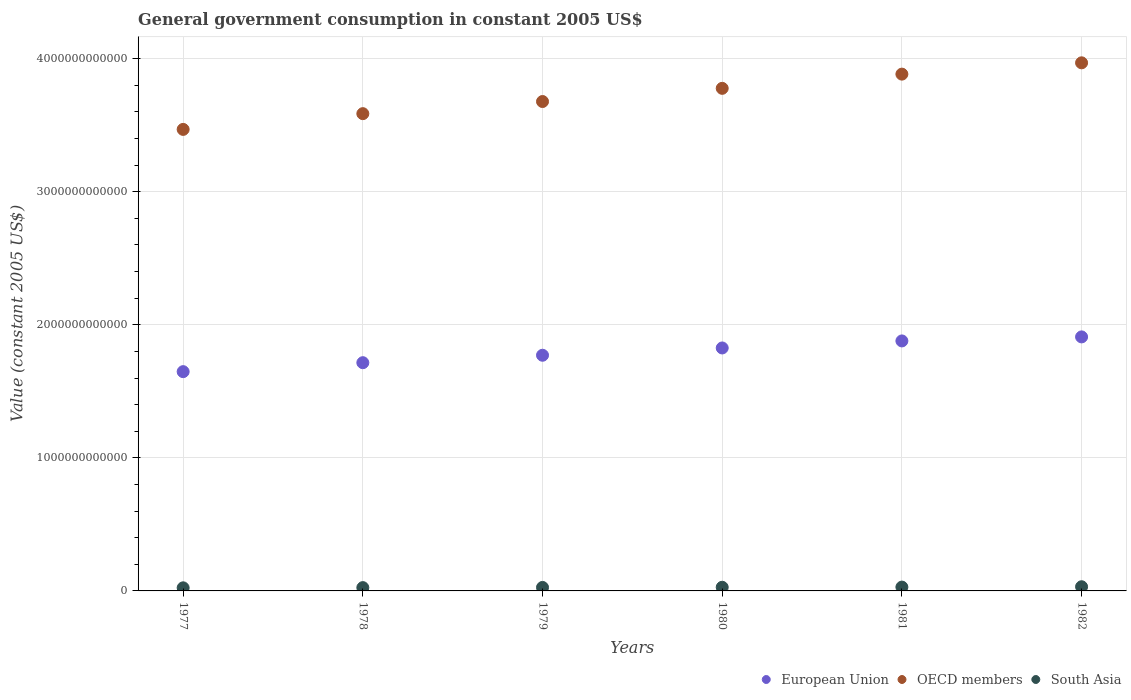What is the government conusmption in OECD members in 1978?
Make the answer very short. 3.59e+12. Across all years, what is the maximum government conusmption in OECD members?
Offer a very short reply. 3.97e+12. Across all years, what is the minimum government conusmption in South Asia?
Provide a short and direct response. 2.33e+1. In which year was the government conusmption in European Union maximum?
Make the answer very short. 1982. In which year was the government conusmption in OECD members minimum?
Provide a short and direct response. 1977. What is the total government conusmption in European Union in the graph?
Provide a succinct answer. 1.07e+13. What is the difference between the government conusmption in European Union in 1977 and that in 1980?
Offer a terse response. -1.78e+11. What is the difference between the government conusmption in South Asia in 1979 and the government conusmption in OECD members in 1981?
Your answer should be compact. -3.86e+12. What is the average government conusmption in European Union per year?
Give a very brief answer. 1.79e+12. In the year 1981, what is the difference between the government conusmption in European Union and government conusmption in OECD members?
Your answer should be compact. -2.01e+12. In how many years, is the government conusmption in OECD members greater than 800000000000 US$?
Provide a short and direct response. 6. What is the ratio of the government conusmption in European Union in 1980 to that in 1982?
Provide a short and direct response. 0.96. Is the government conusmption in European Union in 1979 less than that in 1982?
Ensure brevity in your answer.  Yes. Is the difference between the government conusmption in European Union in 1978 and 1979 greater than the difference between the government conusmption in OECD members in 1978 and 1979?
Make the answer very short. Yes. What is the difference between the highest and the second highest government conusmption in OECD members?
Your answer should be very brief. 8.49e+1. What is the difference between the highest and the lowest government conusmption in South Asia?
Offer a very short reply. 8.10e+09. In how many years, is the government conusmption in European Union greater than the average government conusmption in European Union taken over all years?
Your answer should be very brief. 3. Is it the case that in every year, the sum of the government conusmption in European Union and government conusmption in South Asia  is greater than the government conusmption in OECD members?
Make the answer very short. No. Is the government conusmption in European Union strictly greater than the government conusmption in South Asia over the years?
Your answer should be compact. Yes. Is the government conusmption in European Union strictly less than the government conusmption in South Asia over the years?
Offer a very short reply. No. How many years are there in the graph?
Keep it short and to the point. 6. What is the difference between two consecutive major ticks on the Y-axis?
Your answer should be very brief. 1.00e+12. Does the graph contain grids?
Give a very brief answer. Yes. What is the title of the graph?
Offer a very short reply. General government consumption in constant 2005 US$. What is the label or title of the Y-axis?
Keep it short and to the point. Value (constant 2005 US$). What is the Value (constant 2005 US$) in European Union in 1977?
Your answer should be very brief. 1.65e+12. What is the Value (constant 2005 US$) of OECD members in 1977?
Make the answer very short. 3.47e+12. What is the Value (constant 2005 US$) of South Asia in 1977?
Offer a terse response. 2.33e+1. What is the Value (constant 2005 US$) in European Union in 1978?
Your answer should be compact. 1.72e+12. What is the Value (constant 2005 US$) of OECD members in 1978?
Keep it short and to the point. 3.59e+12. What is the Value (constant 2005 US$) in South Asia in 1978?
Keep it short and to the point. 2.48e+1. What is the Value (constant 2005 US$) of European Union in 1979?
Offer a terse response. 1.77e+12. What is the Value (constant 2005 US$) in OECD members in 1979?
Ensure brevity in your answer.  3.68e+12. What is the Value (constant 2005 US$) of South Asia in 1979?
Give a very brief answer. 2.62e+1. What is the Value (constant 2005 US$) in European Union in 1980?
Make the answer very short. 1.83e+12. What is the Value (constant 2005 US$) in OECD members in 1980?
Keep it short and to the point. 3.78e+12. What is the Value (constant 2005 US$) in South Asia in 1980?
Offer a very short reply. 2.74e+1. What is the Value (constant 2005 US$) of European Union in 1981?
Ensure brevity in your answer.  1.88e+12. What is the Value (constant 2005 US$) of OECD members in 1981?
Give a very brief answer. 3.88e+12. What is the Value (constant 2005 US$) in South Asia in 1981?
Make the answer very short. 2.88e+1. What is the Value (constant 2005 US$) of European Union in 1982?
Offer a terse response. 1.91e+12. What is the Value (constant 2005 US$) in OECD members in 1982?
Your answer should be compact. 3.97e+12. What is the Value (constant 2005 US$) of South Asia in 1982?
Keep it short and to the point. 3.14e+1. Across all years, what is the maximum Value (constant 2005 US$) of European Union?
Provide a succinct answer. 1.91e+12. Across all years, what is the maximum Value (constant 2005 US$) in OECD members?
Your answer should be very brief. 3.97e+12. Across all years, what is the maximum Value (constant 2005 US$) of South Asia?
Give a very brief answer. 3.14e+1. Across all years, what is the minimum Value (constant 2005 US$) of European Union?
Make the answer very short. 1.65e+12. Across all years, what is the minimum Value (constant 2005 US$) of OECD members?
Keep it short and to the point. 3.47e+12. Across all years, what is the minimum Value (constant 2005 US$) of South Asia?
Offer a terse response. 2.33e+1. What is the total Value (constant 2005 US$) of European Union in the graph?
Your answer should be compact. 1.07e+13. What is the total Value (constant 2005 US$) in OECD members in the graph?
Keep it short and to the point. 2.24e+13. What is the total Value (constant 2005 US$) in South Asia in the graph?
Ensure brevity in your answer.  1.62e+11. What is the difference between the Value (constant 2005 US$) in European Union in 1977 and that in 1978?
Provide a succinct answer. -6.73e+1. What is the difference between the Value (constant 2005 US$) in OECD members in 1977 and that in 1978?
Provide a short and direct response. -1.18e+11. What is the difference between the Value (constant 2005 US$) in South Asia in 1977 and that in 1978?
Make the answer very short. -1.54e+09. What is the difference between the Value (constant 2005 US$) of European Union in 1977 and that in 1979?
Provide a succinct answer. -1.23e+11. What is the difference between the Value (constant 2005 US$) of OECD members in 1977 and that in 1979?
Offer a terse response. -2.10e+11. What is the difference between the Value (constant 2005 US$) of South Asia in 1977 and that in 1979?
Offer a terse response. -2.97e+09. What is the difference between the Value (constant 2005 US$) in European Union in 1977 and that in 1980?
Offer a very short reply. -1.78e+11. What is the difference between the Value (constant 2005 US$) of OECD members in 1977 and that in 1980?
Keep it short and to the point. -3.09e+11. What is the difference between the Value (constant 2005 US$) in South Asia in 1977 and that in 1980?
Keep it short and to the point. -4.13e+09. What is the difference between the Value (constant 2005 US$) in European Union in 1977 and that in 1981?
Make the answer very short. -2.31e+11. What is the difference between the Value (constant 2005 US$) in OECD members in 1977 and that in 1981?
Your answer should be very brief. -4.15e+11. What is the difference between the Value (constant 2005 US$) in South Asia in 1977 and that in 1981?
Your answer should be compact. -5.49e+09. What is the difference between the Value (constant 2005 US$) of European Union in 1977 and that in 1982?
Offer a very short reply. -2.61e+11. What is the difference between the Value (constant 2005 US$) in OECD members in 1977 and that in 1982?
Ensure brevity in your answer.  -5.00e+11. What is the difference between the Value (constant 2005 US$) in South Asia in 1977 and that in 1982?
Make the answer very short. -8.10e+09. What is the difference between the Value (constant 2005 US$) in European Union in 1978 and that in 1979?
Ensure brevity in your answer.  -5.59e+1. What is the difference between the Value (constant 2005 US$) in OECD members in 1978 and that in 1979?
Provide a short and direct response. -9.12e+1. What is the difference between the Value (constant 2005 US$) in South Asia in 1978 and that in 1979?
Your response must be concise. -1.43e+09. What is the difference between the Value (constant 2005 US$) of European Union in 1978 and that in 1980?
Ensure brevity in your answer.  -1.11e+11. What is the difference between the Value (constant 2005 US$) in OECD members in 1978 and that in 1980?
Keep it short and to the point. -1.90e+11. What is the difference between the Value (constant 2005 US$) in South Asia in 1978 and that in 1980?
Your response must be concise. -2.59e+09. What is the difference between the Value (constant 2005 US$) of European Union in 1978 and that in 1981?
Offer a very short reply. -1.64e+11. What is the difference between the Value (constant 2005 US$) in OECD members in 1978 and that in 1981?
Offer a terse response. -2.97e+11. What is the difference between the Value (constant 2005 US$) in South Asia in 1978 and that in 1981?
Give a very brief answer. -3.95e+09. What is the difference between the Value (constant 2005 US$) in European Union in 1978 and that in 1982?
Keep it short and to the point. -1.94e+11. What is the difference between the Value (constant 2005 US$) of OECD members in 1978 and that in 1982?
Provide a succinct answer. -3.82e+11. What is the difference between the Value (constant 2005 US$) of South Asia in 1978 and that in 1982?
Keep it short and to the point. -6.56e+09. What is the difference between the Value (constant 2005 US$) of European Union in 1979 and that in 1980?
Your response must be concise. -5.47e+1. What is the difference between the Value (constant 2005 US$) in OECD members in 1979 and that in 1980?
Provide a succinct answer. -9.91e+1. What is the difference between the Value (constant 2005 US$) of South Asia in 1979 and that in 1980?
Give a very brief answer. -1.16e+09. What is the difference between the Value (constant 2005 US$) of European Union in 1979 and that in 1981?
Ensure brevity in your answer.  -1.08e+11. What is the difference between the Value (constant 2005 US$) in OECD members in 1979 and that in 1981?
Provide a succinct answer. -2.06e+11. What is the difference between the Value (constant 2005 US$) of South Asia in 1979 and that in 1981?
Offer a very short reply. -2.52e+09. What is the difference between the Value (constant 2005 US$) of European Union in 1979 and that in 1982?
Make the answer very short. -1.38e+11. What is the difference between the Value (constant 2005 US$) in OECD members in 1979 and that in 1982?
Ensure brevity in your answer.  -2.91e+11. What is the difference between the Value (constant 2005 US$) of South Asia in 1979 and that in 1982?
Provide a short and direct response. -5.13e+09. What is the difference between the Value (constant 2005 US$) of European Union in 1980 and that in 1981?
Provide a succinct answer. -5.29e+1. What is the difference between the Value (constant 2005 US$) of OECD members in 1980 and that in 1981?
Offer a terse response. -1.07e+11. What is the difference between the Value (constant 2005 US$) in South Asia in 1980 and that in 1981?
Keep it short and to the point. -1.36e+09. What is the difference between the Value (constant 2005 US$) of European Union in 1980 and that in 1982?
Provide a succinct answer. -8.31e+1. What is the difference between the Value (constant 2005 US$) in OECD members in 1980 and that in 1982?
Keep it short and to the point. -1.92e+11. What is the difference between the Value (constant 2005 US$) in South Asia in 1980 and that in 1982?
Keep it short and to the point. -3.97e+09. What is the difference between the Value (constant 2005 US$) in European Union in 1981 and that in 1982?
Give a very brief answer. -3.03e+1. What is the difference between the Value (constant 2005 US$) of OECD members in 1981 and that in 1982?
Your answer should be very brief. -8.49e+1. What is the difference between the Value (constant 2005 US$) of South Asia in 1981 and that in 1982?
Your response must be concise. -2.61e+09. What is the difference between the Value (constant 2005 US$) in European Union in 1977 and the Value (constant 2005 US$) in OECD members in 1978?
Your answer should be compact. -1.94e+12. What is the difference between the Value (constant 2005 US$) in European Union in 1977 and the Value (constant 2005 US$) in South Asia in 1978?
Make the answer very short. 1.62e+12. What is the difference between the Value (constant 2005 US$) of OECD members in 1977 and the Value (constant 2005 US$) of South Asia in 1978?
Give a very brief answer. 3.44e+12. What is the difference between the Value (constant 2005 US$) of European Union in 1977 and the Value (constant 2005 US$) of OECD members in 1979?
Offer a very short reply. -2.03e+12. What is the difference between the Value (constant 2005 US$) of European Union in 1977 and the Value (constant 2005 US$) of South Asia in 1979?
Your response must be concise. 1.62e+12. What is the difference between the Value (constant 2005 US$) in OECD members in 1977 and the Value (constant 2005 US$) in South Asia in 1979?
Provide a succinct answer. 3.44e+12. What is the difference between the Value (constant 2005 US$) of European Union in 1977 and the Value (constant 2005 US$) of OECD members in 1980?
Ensure brevity in your answer.  -2.13e+12. What is the difference between the Value (constant 2005 US$) in European Union in 1977 and the Value (constant 2005 US$) in South Asia in 1980?
Your answer should be very brief. 1.62e+12. What is the difference between the Value (constant 2005 US$) of OECD members in 1977 and the Value (constant 2005 US$) of South Asia in 1980?
Keep it short and to the point. 3.44e+12. What is the difference between the Value (constant 2005 US$) of European Union in 1977 and the Value (constant 2005 US$) of OECD members in 1981?
Ensure brevity in your answer.  -2.24e+12. What is the difference between the Value (constant 2005 US$) in European Union in 1977 and the Value (constant 2005 US$) in South Asia in 1981?
Your response must be concise. 1.62e+12. What is the difference between the Value (constant 2005 US$) of OECD members in 1977 and the Value (constant 2005 US$) of South Asia in 1981?
Ensure brevity in your answer.  3.44e+12. What is the difference between the Value (constant 2005 US$) of European Union in 1977 and the Value (constant 2005 US$) of OECD members in 1982?
Give a very brief answer. -2.32e+12. What is the difference between the Value (constant 2005 US$) of European Union in 1977 and the Value (constant 2005 US$) of South Asia in 1982?
Your response must be concise. 1.62e+12. What is the difference between the Value (constant 2005 US$) in OECD members in 1977 and the Value (constant 2005 US$) in South Asia in 1982?
Keep it short and to the point. 3.44e+12. What is the difference between the Value (constant 2005 US$) in European Union in 1978 and the Value (constant 2005 US$) in OECD members in 1979?
Provide a short and direct response. -1.96e+12. What is the difference between the Value (constant 2005 US$) in European Union in 1978 and the Value (constant 2005 US$) in South Asia in 1979?
Give a very brief answer. 1.69e+12. What is the difference between the Value (constant 2005 US$) in OECD members in 1978 and the Value (constant 2005 US$) in South Asia in 1979?
Make the answer very short. 3.56e+12. What is the difference between the Value (constant 2005 US$) in European Union in 1978 and the Value (constant 2005 US$) in OECD members in 1980?
Provide a short and direct response. -2.06e+12. What is the difference between the Value (constant 2005 US$) in European Union in 1978 and the Value (constant 2005 US$) in South Asia in 1980?
Offer a very short reply. 1.69e+12. What is the difference between the Value (constant 2005 US$) in OECD members in 1978 and the Value (constant 2005 US$) in South Asia in 1980?
Keep it short and to the point. 3.56e+12. What is the difference between the Value (constant 2005 US$) of European Union in 1978 and the Value (constant 2005 US$) of OECD members in 1981?
Ensure brevity in your answer.  -2.17e+12. What is the difference between the Value (constant 2005 US$) in European Union in 1978 and the Value (constant 2005 US$) in South Asia in 1981?
Offer a terse response. 1.69e+12. What is the difference between the Value (constant 2005 US$) in OECD members in 1978 and the Value (constant 2005 US$) in South Asia in 1981?
Keep it short and to the point. 3.56e+12. What is the difference between the Value (constant 2005 US$) in European Union in 1978 and the Value (constant 2005 US$) in OECD members in 1982?
Your answer should be very brief. -2.25e+12. What is the difference between the Value (constant 2005 US$) of European Union in 1978 and the Value (constant 2005 US$) of South Asia in 1982?
Your response must be concise. 1.68e+12. What is the difference between the Value (constant 2005 US$) in OECD members in 1978 and the Value (constant 2005 US$) in South Asia in 1982?
Make the answer very short. 3.56e+12. What is the difference between the Value (constant 2005 US$) in European Union in 1979 and the Value (constant 2005 US$) in OECD members in 1980?
Provide a short and direct response. -2.01e+12. What is the difference between the Value (constant 2005 US$) of European Union in 1979 and the Value (constant 2005 US$) of South Asia in 1980?
Keep it short and to the point. 1.74e+12. What is the difference between the Value (constant 2005 US$) of OECD members in 1979 and the Value (constant 2005 US$) of South Asia in 1980?
Ensure brevity in your answer.  3.65e+12. What is the difference between the Value (constant 2005 US$) of European Union in 1979 and the Value (constant 2005 US$) of OECD members in 1981?
Make the answer very short. -2.11e+12. What is the difference between the Value (constant 2005 US$) of European Union in 1979 and the Value (constant 2005 US$) of South Asia in 1981?
Keep it short and to the point. 1.74e+12. What is the difference between the Value (constant 2005 US$) of OECD members in 1979 and the Value (constant 2005 US$) of South Asia in 1981?
Ensure brevity in your answer.  3.65e+12. What is the difference between the Value (constant 2005 US$) of European Union in 1979 and the Value (constant 2005 US$) of OECD members in 1982?
Make the answer very short. -2.20e+12. What is the difference between the Value (constant 2005 US$) of European Union in 1979 and the Value (constant 2005 US$) of South Asia in 1982?
Keep it short and to the point. 1.74e+12. What is the difference between the Value (constant 2005 US$) of OECD members in 1979 and the Value (constant 2005 US$) of South Asia in 1982?
Your answer should be very brief. 3.65e+12. What is the difference between the Value (constant 2005 US$) of European Union in 1980 and the Value (constant 2005 US$) of OECD members in 1981?
Offer a terse response. -2.06e+12. What is the difference between the Value (constant 2005 US$) in European Union in 1980 and the Value (constant 2005 US$) in South Asia in 1981?
Your answer should be very brief. 1.80e+12. What is the difference between the Value (constant 2005 US$) of OECD members in 1980 and the Value (constant 2005 US$) of South Asia in 1981?
Keep it short and to the point. 3.75e+12. What is the difference between the Value (constant 2005 US$) in European Union in 1980 and the Value (constant 2005 US$) in OECD members in 1982?
Offer a very short reply. -2.14e+12. What is the difference between the Value (constant 2005 US$) of European Union in 1980 and the Value (constant 2005 US$) of South Asia in 1982?
Your answer should be compact. 1.79e+12. What is the difference between the Value (constant 2005 US$) in OECD members in 1980 and the Value (constant 2005 US$) in South Asia in 1982?
Provide a short and direct response. 3.75e+12. What is the difference between the Value (constant 2005 US$) in European Union in 1981 and the Value (constant 2005 US$) in OECD members in 1982?
Ensure brevity in your answer.  -2.09e+12. What is the difference between the Value (constant 2005 US$) of European Union in 1981 and the Value (constant 2005 US$) of South Asia in 1982?
Your answer should be compact. 1.85e+12. What is the difference between the Value (constant 2005 US$) in OECD members in 1981 and the Value (constant 2005 US$) in South Asia in 1982?
Give a very brief answer. 3.85e+12. What is the average Value (constant 2005 US$) in European Union per year?
Offer a terse response. 1.79e+12. What is the average Value (constant 2005 US$) in OECD members per year?
Give a very brief answer. 3.73e+12. What is the average Value (constant 2005 US$) of South Asia per year?
Provide a short and direct response. 2.70e+1. In the year 1977, what is the difference between the Value (constant 2005 US$) in European Union and Value (constant 2005 US$) in OECD members?
Give a very brief answer. -1.82e+12. In the year 1977, what is the difference between the Value (constant 2005 US$) in European Union and Value (constant 2005 US$) in South Asia?
Offer a terse response. 1.62e+12. In the year 1977, what is the difference between the Value (constant 2005 US$) in OECD members and Value (constant 2005 US$) in South Asia?
Provide a short and direct response. 3.45e+12. In the year 1978, what is the difference between the Value (constant 2005 US$) in European Union and Value (constant 2005 US$) in OECD members?
Your answer should be compact. -1.87e+12. In the year 1978, what is the difference between the Value (constant 2005 US$) in European Union and Value (constant 2005 US$) in South Asia?
Your answer should be compact. 1.69e+12. In the year 1978, what is the difference between the Value (constant 2005 US$) of OECD members and Value (constant 2005 US$) of South Asia?
Keep it short and to the point. 3.56e+12. In the year 1979, what is the difference between the Value (constant 2005 US$) in European Union and Value (constant 2005 US$) in OECD members?
Offer a terse response. -1.91e+12. In the year 1979, what is the difference between the Value (constant 2005 US$) of European Union and Value (constant 2005 US$) of South Asia?
Provide a short and direct response. 1.75e+12. In the year 1979, what is the difference between the Value (constant 2005 US$) of OECD members and Value (constant 2005 US$) of South Asia?
Keep it short and to the point. 3.65e+12. In the year 1980, what is the difference between the Value (constant 2005 US$) of European Union and Value (constant 2005 US$) of OECD members?
Ensure brevity in your answer.  -1.95e+12. In the year 1980, what is the difference between the Value (constant 2005 US$) of European Union and Value (constant 2005 US$) of South Asia?
Your answer should be very brief. 1.80e+12. In the year 1980, what is the difference between the Value (constant 2005 US$) in OECD members and Value (constant 2005 US$) in South Asia?
Your response must be concise. 3.75e+12. In the year 1981, what is the difference between the Value (constant 2005 US$) in European Union and Value (constant 2005 US$) in OECD members?
Provide a short and direct response. -2.01e+12. In the year 1981, what is the difference between the Value (constant 2005 US$) of European Union and Value (constant 2005 US$) of South Asia?
Your answer should be compact. 1.85e+12. In the year 1981, what is the difference between the Value (constant 2005 US$) in OECD members and Value (constant 2005 US$) in South Asia?
Your response must be concise. 3.86e+12. In the year 1982, what is the difference between the Value (constant 2005 US$) in European Union and Value (constant 2005 US$) in OECD members?
Offer a very short reply. -2.06e+12. In the year 1982, what is the difference between the Value (constant 2005 US$) in European Union and Value (constant 2005 US$) in South Asia?
Provide a short and direct response. 1.88e+12. In the year 1982, what is the difference between the Value (constant 2005 US$) of OECD members and Value (constant 2005 US$) of South Asia?
Make the answer very short. 3.94e+12. What is the ratio of the Value (constant 2005 US$) in European Union in 1977 to that in 1978?
Make the answer very short. 0.96. What is the ratio of the Value (constant 2005 US$) in OECD members in 1977 to that in 1978?
Provide a short and direct response. 0.97. What is the ratio of the Value (constant 2005 US$) of South Asia in 1977 to that in 1978?
Keep it short and to the point. 0.94. What is the ratio of the Value (constant 2005 US$) in European Union in 1977 to that in 1979?
Give a very brief answer. 0.93. What is the ratio of the Value (constant 2005 US$) in OECD members in 1977 to that in 1979?
Provide a short and direct response. 0.94. What is the ratio of the Value (constant 2005 US$) in South Asia in 1977 to that in 1979?
Keep it short and to the point. 0.89. What is the ratio of the Value (constant 2005 US$) of European Union in 1977 to that in 1980?
Make the answer very short. 0.9. What is the ratio of the Value (constant 2005 US$) of OECD members in 1977 to that in 1980?
Offer a very short reply. 0.92. What is the ratio of the Value (constant 2005 US$) of South Asia in 1977 to that in 1980?
Offer a terse response. 0.85. What is the ratio of the Value (constant 2005 US$) of European Union in 1977 to that in 1981?
Offer a very short reply. 0.88. What is the ratio of the Value (constant 2005 US$) of OECD members in 1977 to that in 1981?
Your answer should be compact. 0.89. What is the ratio of the Value (constant 2005 US$) of South Asia in 1977 to that in 1981?
Offer a very short reply. 0.81. What is the ratio of the Value (constant 2005 US$) of European Union in 1977 to that in 1982?
Provide a short and direct response. 0.86. What is the ratio of the Value (constant 2005 US$) of OECD members in 1977 to that in 1982?
Offer a terse response. 0.87. What is the ratio of the Value (constant 2005 US$) of South Asia in 1977 to that in 1982?
Your answer should be very brief. 0.74. What is the ratio of the Value (constant 2005 US$) in European Union in 1978 to that in 1979?
Keep it short and to the point. 0.97. What is the ratio of the Value (constant 2005 US$) in OECD members in 1978 to that in 1979?
Make the answer very short. 0.98. What is the ratio of the Value (constant 2005 US$) in South Asia in 1978 to that in 1979?
Your answer should be very brief. 0.95. What is the ratio of the Value (constant 2005 US$) in European Union in 1978 to that in 1980?
Offer a very short reply. 0.94. What is the ratio of the Value (constant 2005 US$) of OECD members in 1978 to that in 1980?
Provide a succinct answer. 0.95. What is the ratio of the Value (constant 2005 US$) in South Asia in 1978 to that in 1980?
Offer a terse response. 0.91. What is the ratio of the Value (constant 2005 US$) in European Union in 1978 to that in 1981?
Make the answer very short. 0.91. What is the ratio of the Value (constant 2005 US$) of OECD members in 1978 to that in 1981?
Your answer should be compact. 0.92. What is the ratio of the Value (constant 2005 US$) in South Asia in 1978 to that in 1981?
Your answer should be compact. 0.86. What is the ratio of the Value (constant 2005 US$) of European Union in 1978 to that in 1982?
Provide a succinct answer. 0.9. What is the ratio of the Value (constant 2005 US$) of OECD members in 1978 to that in 1982?
Make the answer very short. 0.9. What is the ratio of the Value (constant 2005 US$) of South Asia in 1978 to that in 1982?
Ensure brevity in your answer.  0.79. What is the ratio of the Value (constant 2005 US$) in OECD members in 1979 to that in 1980?
Your response must be concise. 0.97. What is the ratio of the Value (constant 2005 US$) in South Asia in 1979 to that in 1980?
Make the answer very short. 0.96. What is the ratio of the Value (constant 2005 US$) of European Union in 1979 to that in 1981?
Offer a terse response. 0.94. What is the ratio of the Value (constant 2005 US$) in OECD members in 1979 to that in 1981?
Provide a succinct answer. 0.95. What is the ratio of the Value (constant 2005 US$) in South Asia in 1979 to that in 1981?
Provide a succinct answer. 0.91. What is the ratio of the Value (constant 2005 US$) in European Union in 1979 to that in 1982?
Keep it short and to the point. 0.93. What is the ratio of the Value (constant 2005 US$) in OECD members in 1979 to that in 1982?
Provide a short and direct response. 0.93. What is the ratio of the Value (constant 2005 US$) in South Asia in 1979 to that in 1982?
Offer a very short reply. 0.84. What is the ratio of the Value (constant 2005 US$) in European Union in 1980 to that in 1981?
Provide a short and direct response. 0.97. What is the ratio of the Value (constant 2005 US$) of OECD members in 1980 to that in 1981?
Your response must be concise. 0.97. What is the ratio of the Value (constant 2005 US$) in South Asia in 1980 to that in 1981?
Provide a succinct answer. 0.95. What is the ratio of the Value (constant 2005 US$) in European Union in 1980 to that in 1982?
Ensure brevity in your answer.  0.96. What is the ratio of the Value (constant 2005 US$) in OECD members in 1980 to that in 1982?
Provide a short and direct response. 0.95. What is the ratio of the Value (constant 2005 US$) of South Asia in 1980 to that in 1982?
Make the answer very short. 0.87. What is the ratio of the Value (constant 2005 US$) in European Union in 1981 to that in 1982?
Your answer should be compact. 0.98. What is the ratio of the Value (constant 2005 US$) of OECD members in 1981 to that in 1982?
Offer a very short reply. 0.98. What is the difference between the highest and the second highest Value (constant 2005 US$) of European Union?
Ensure brevity in your answer.  3.03e+1. What is the difference between the highest and the second highest Value (constant 2005 US$) in OECD members?
Give a very brief answer. 8.49e+1. What is the difference between the highest and the second highest Value (constant 2005 US$) in South Asia?
Your response must be concise. 2.61e+09. What is the difference between the highest and the lowest Value (constant 2005 US$) in European Union?
Provide a short and direct response. 2.61e+11. What is the difference between the highest and the lowest Value (constant 2005 US$) of OECD members?
Your answer should be compact. 5.00e+11. What is the difference between the highest and the lowest Value (constant 2005 US$) of South Asia?
Provide a short and direct response. 8.10e+09. 